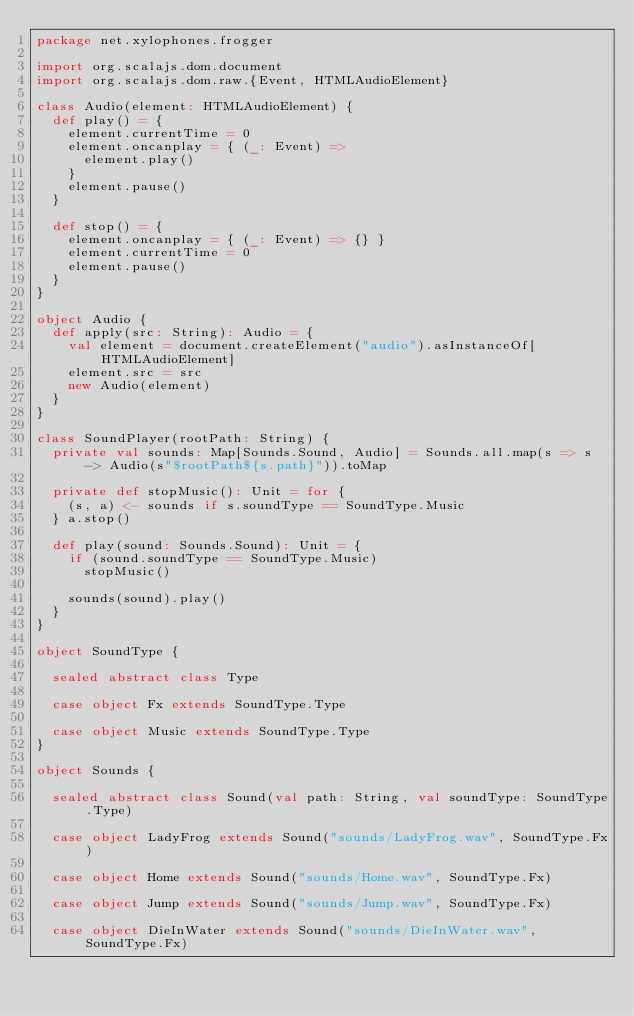<code> <loc_0><loc_0><loc_500><loc_500><_Scala_>package net.xylophones.frogger

import org.scalajs.dom.document
import org.scalajs.dom.raw.{Event, HTMLAudioElement}

class Audio(element: HTMLAudioElement) {
  def play() = {
    element.currentTime = 0
    element.oncanplay = { (_: Event) =>
      element.play()
    }
    element.pause()
  }

  def stop() = {
    element.oncanplay = { (_: Event) => {} }
    element.currentTime = 0
    element.pause()
  }
}

object Audio {
  def apply(src: String): Audio = {
    val element = document.createElement("audio").asInstanceOf[HTMLAudioElement]
    element.src = src
    new Audio(element)
  }
}

class SoundPlayer(rootPath: String) {
  private val sounds: Map[Sounds.Sound, Audio] = Sounds.all.map(s => s -> Audio(s"$rootPath${s.path}")).toMap

  private def stopMusic(): Unit = for {
    (s, a) <- sounds if s.soundType == SoundType.Music
  } a.stop()

  def play(sound: Sounds.Sound): Unit = {
    if (sound.soundType == SoundType.Music)
      stopMusic()

    sounds(sound).play()
  }
}

object SoundType {

  sealed abstract class Type

  case object Fx extends SoundType.Type

  case object Music extends SoundType.Type
}

object Sounds {

  sealed abstract class Sound(val path: String, val soundType: SoundType.Type)

  case object LadyFrog extends Sound("sounds/LadyFrog.wav", SoundType.Fx)

  case object Home extends Sound("sounds/Home.wav", SoundType.Fx)

  case object Jump extends Sound("sounds/Jump.wav", SoundType.Fx)

  case object DieInWater extends Sound("sounds/DieInWater.wav", SoundType.Fx)
</code> 